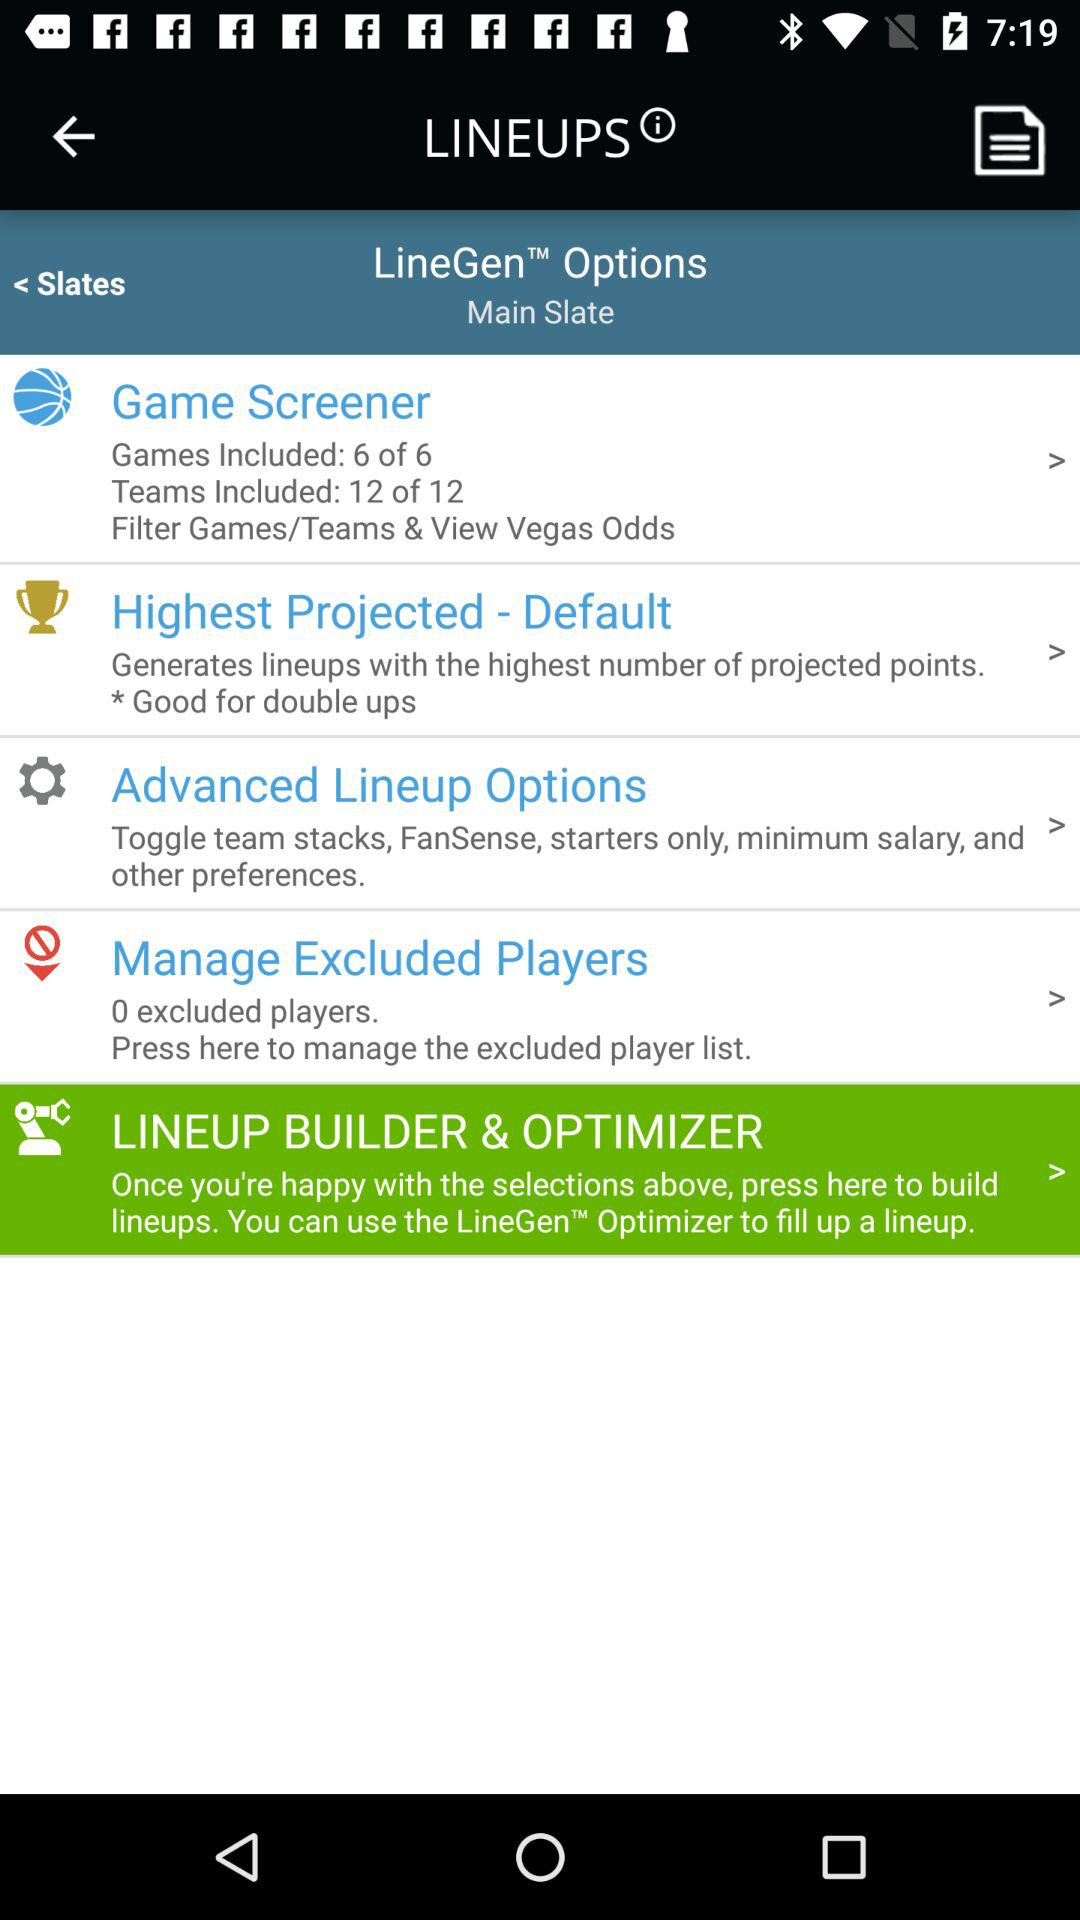What are the settings of the highest projected?
When the provided information is insufficient, respond with <no answer>. <no answer> 